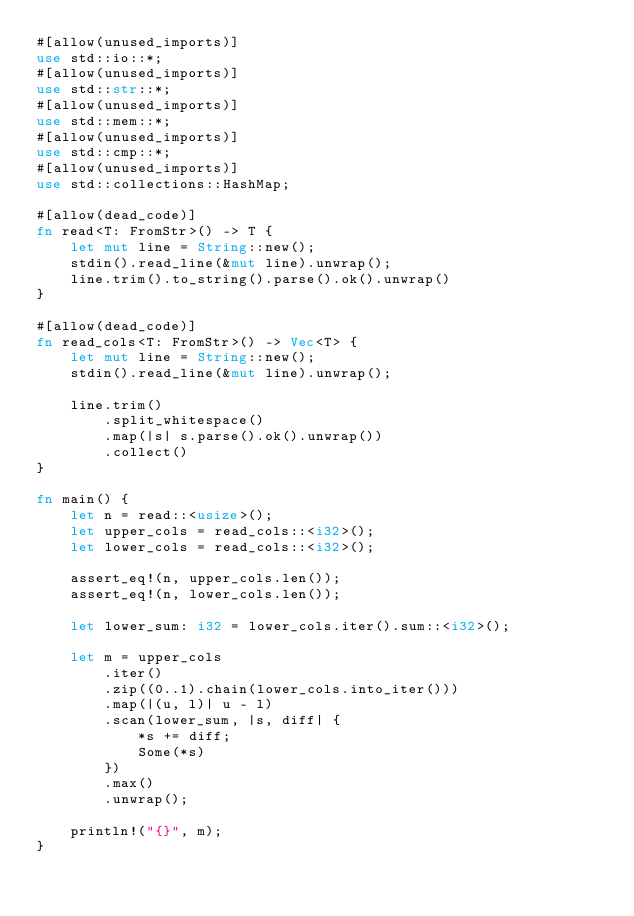<code> <loc_0><loc_0><loc_500><loc_500><_Rust_>#[allow(unused_imports)]
use std::io::*;
#[allow(unused_imports)]
use std::str::*;
#[allow(unused_imports)]
use std::mem::*;
#[allow(unused_imports)]
use std::cmp::*;
#[allow(unused_imports)]
use std::collections::HashMap;

#[allow(dead_code)]
fn read<T: FromStr>() -> T {
    let mut line = String::new();
    stdin().read_line(&mut line).unwrap();
    line.trim().to_string().parse().ok().unwrap()
}

#[allow(dead_code)]
fn read_cols<T: FromStr>() -> Vec<T> {
    let mut line = String::new();
    stdin().read_line(&mut line).unwrap();

    line.trim()
        .split_whitespace()
        .map(|s| s.parse().ok().unwrap())
        .collect()
}

fn main() {
    let n = read::<usize>();
    let upper_cols = read_cols::<i32>();
    let lower_cols = read_cols::<i32>();

    assert_eq!(n, upper_cols.len());
    assert_eq!(n, lower_cols.len());

    let lower_sum: i32 = lower_cols.iter().sum::<i32>();

    let m = upper_cols
        .iter()
        .zip((0..1).chain(lower_cols.into_iter()))
        .map(|(u, l)| u - l)
        .scan(lower_sum, |s, diff| {
            *s += diff;
            Some(*s)
        })
        .max()
        .unwrap();

    println!("{}", m);
}
</code> 